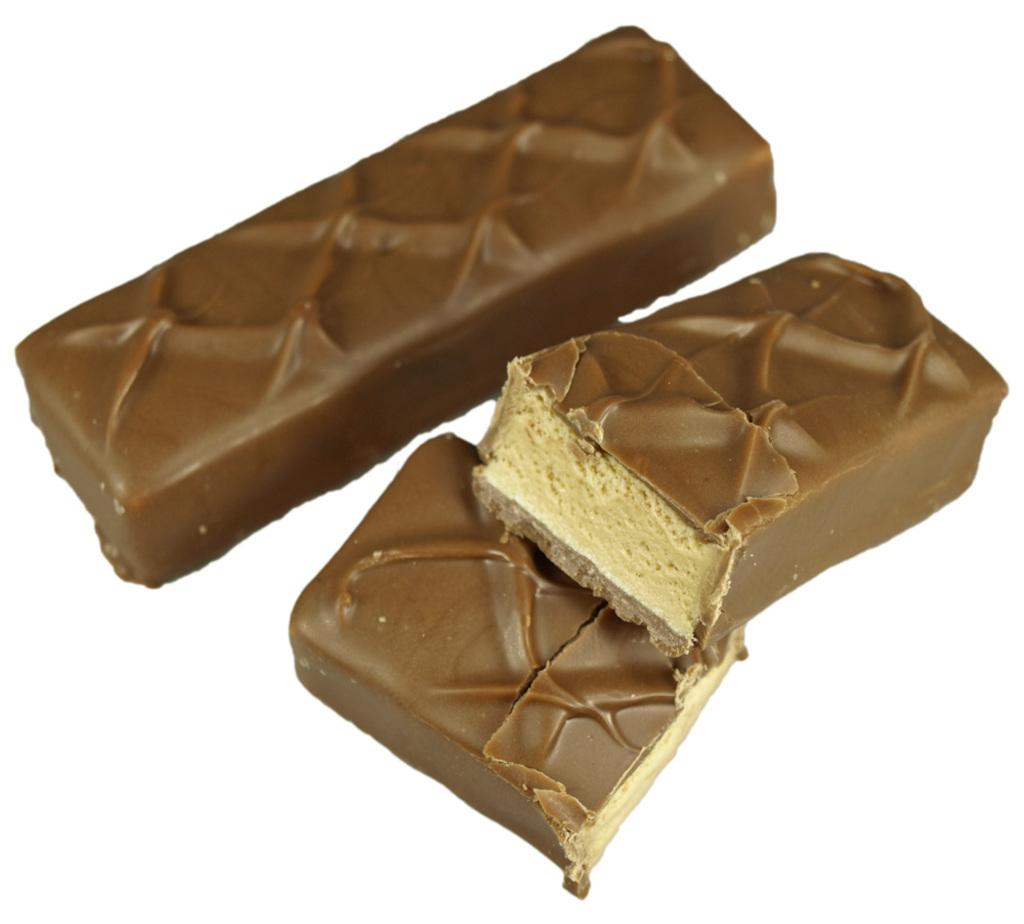What type of food is present in the image? There are chocolates in the image. What is the color of the surface on which the chocolates are placed? The chocolates are on a white surface. How does the moon affect the distribution of chocolates in the image? The moon does not affect the distribution of chocolates in the image, as the moon is not present in the image. 